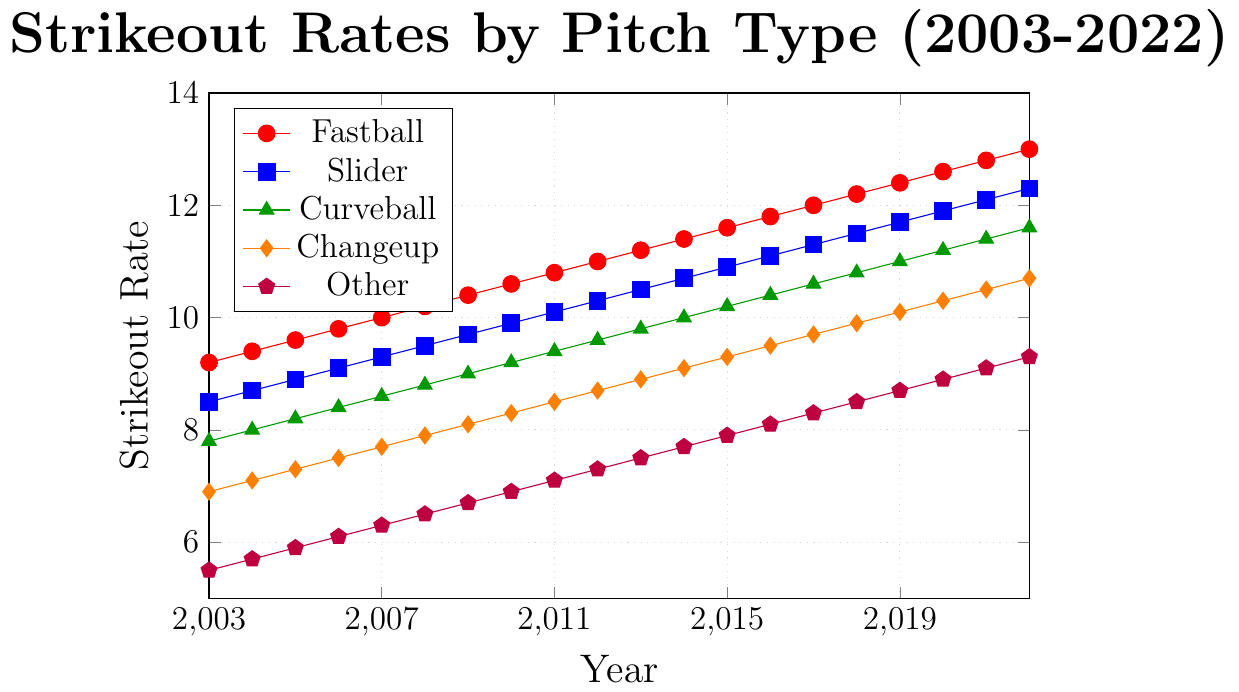Which pitch type has the highest strikeout rate in 2022? Look for the point in 2022 on each line and identify the highest value. Fastball has a strikeout rate of 13.0 in 2022, which is the highest among the pitch types.
Answer: Fastball Which pitch type shows the least improvement in strikeout rate from 2003 to 2022? Calculate the difference in strikeout rate for each pitch type between 2003 and 2022. The differences are: Fastball (13.0 - 9.2 = 3.8), Slider (12.3 - 8.5 = 3.8), Curveball (11.6 - 7.8 = 3.8), Changeup (10.7 - 6.9 = 3.8), and Other (9.3 - 5.5 = 3.8). All pitch types have the same improvement of 3.8.
Answer: All pitch types (3.8) What is the average strikeout rate of Sliders from 2015 to 2020? Sum the strikeout rates of Sliders from 2015 to 2020 and divide by the number of years. (10.9 + 11.1 + 11.3 + 11.5 + 11.7 + 11.9)/6 = 68.4/6
Answer: 11.4 Which pitch type has the most consistent increase in strikeout rate over the years? Compare the consistency in increase for each pitch type by visually assessing the smoothness and steadiness of the lines. Fastball has the smoothest and most consistent increase over the 20 years.
Answer: Fastball In which year-interval did the Changeup show the most significant improvement in strikeout rate? Look for the steepest slope in the Changeup line from one year to the next. From 2021 to 2022, Changeup's strikeout rate improves from 10.5 to 10.7, the highest annual increase (0.2).
Answer: 2021-2022 What was the difference in strikeout rate between Fastballs and Curveballs in 2010? Identify the points for Fastballs and Curveballs in 2010, then calculate the difference. Fastball in 2010: 10.6, Curveball in 2010: 9.2. Difference: 10.6 - 9.2
Answer: 1.4 Which pitch type had the lowest average strikeout rate over the 20-year period? Calculate the average for each pitch type and compare. Other has consistently the lowest values each year.
Answer: Other Did any pitch type's strikeout rate decline or remain static for any year during this period? Examine each line to see if any dips or flat lines occur. All lines show a consistent increase with no dips or static periods.
Answer: No 